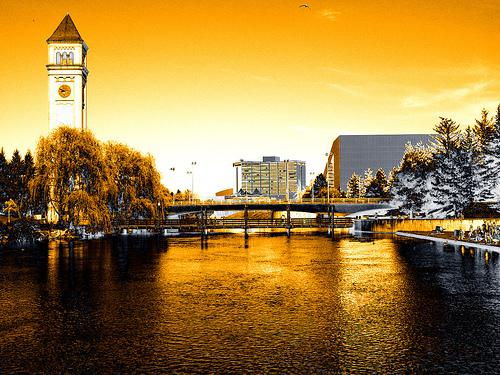Question: what is over the water?
Choices:
A. Fog.
B. Bridge.
C. A boat.
D. A plane.
Answer with the letter. Answer: B Question: where is this location?
Choices:
A. Town.
B. Hollywood.
C. Memphis.
D. Chattanooga.
Answer with the letter. Answer: A Question: why is the sky yellow?
Choices:
A. Light refraction.
B. There is a fire closeby.
C. The sun is coming up.
D. Sunset.
Answer with the letter. Answer: D 